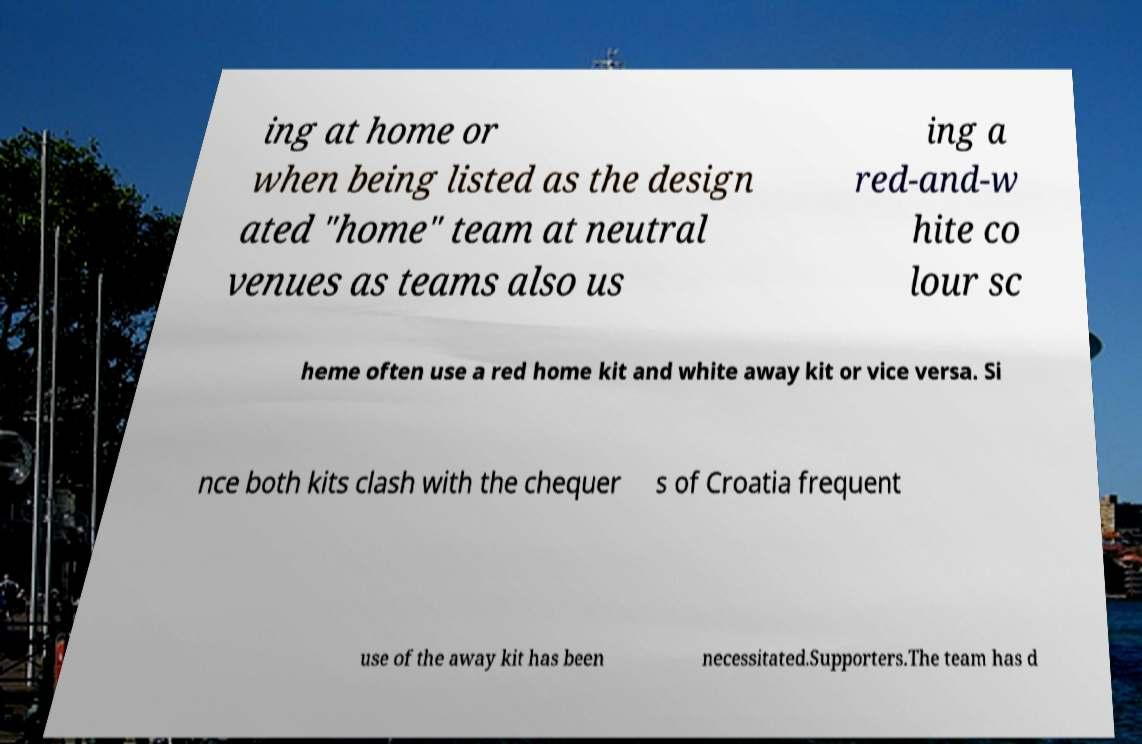Can you accurately transcribe the text from the provided image for me? ing at home or when being listed as the design ated "home" team at neutral venues as teams also us ing a red-and-w hite co lour sc heme often use a red home kit and white away kit or vice versa. Si nce both kits clash with the chequer s of Croatia frequent use of the away kit has been necessitated.Supporters.The team has d 